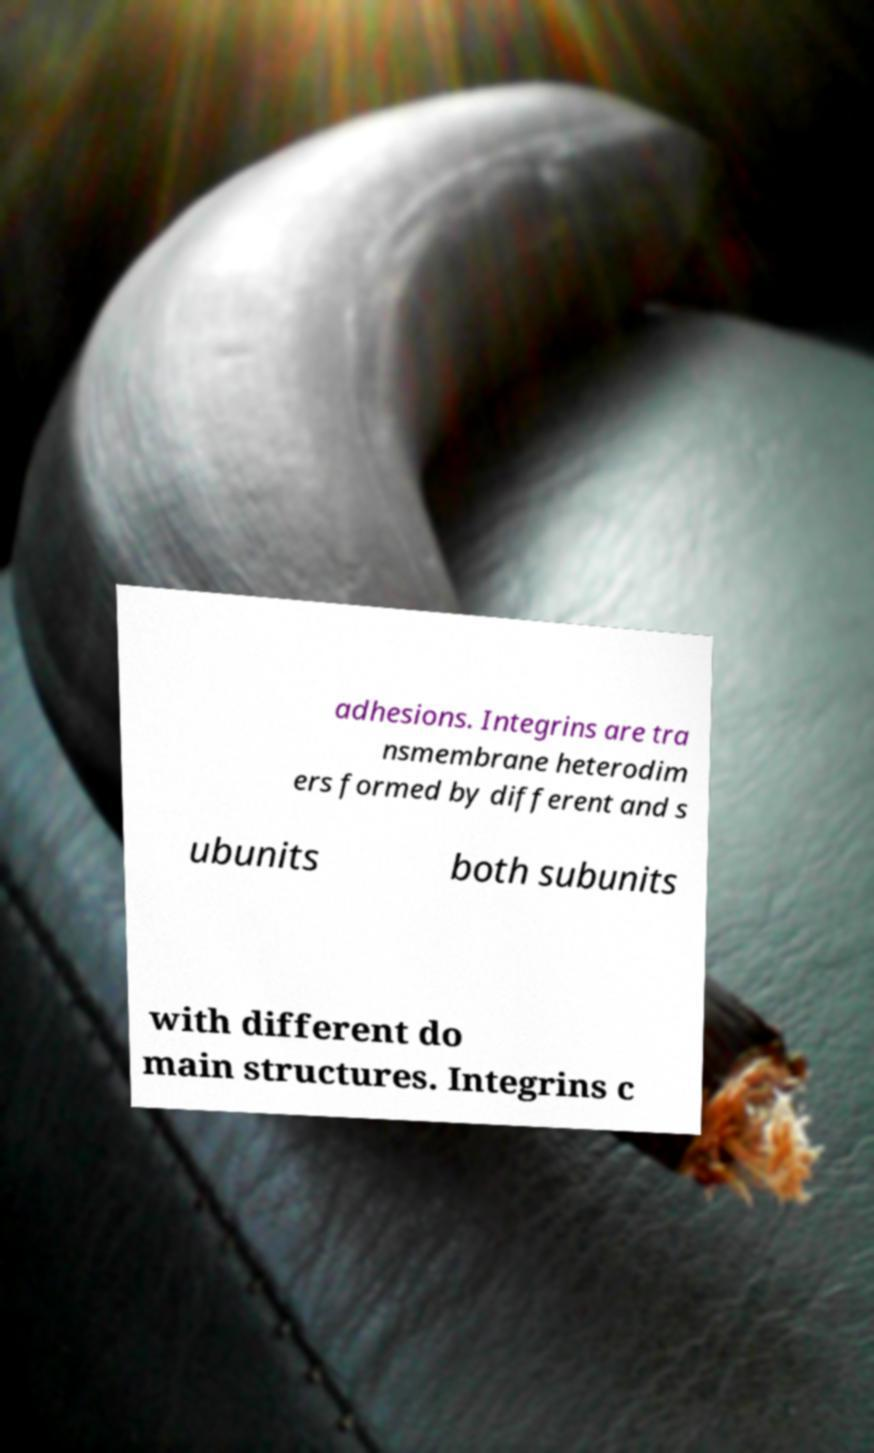Can you accurately transcribe the text from the provided image for me? adhesions. Integrins are tra nsmembrane heterodim ers formed by different and s ubunits both subunits with different do main structures. Integrins c 